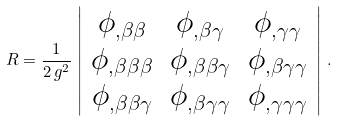Convert formula to latex. <formula><loc_0><loc_0><loc_500><loc_500>R = \frac { 1 } { 2 \, g ^ { 2 } } \, \left | \begin{array} { c c c } \phi _ { , \beta \beta } & \phi _ { , \beta \gamma } & \phi _ { , \gamma \gamma } \\ \phi _ { , \beta \beta \beta } & \phi _ { , \beta \beta \gamma } & \phi _ { , \beta \gamma \gamma } \\ \phi _ { , \beta \beta \gamma } & \phi _ { , \beta \gamma \gamma } & \phi _ { , \gamma \gamma \gamma } \end{array} \right | \, .</formula> 